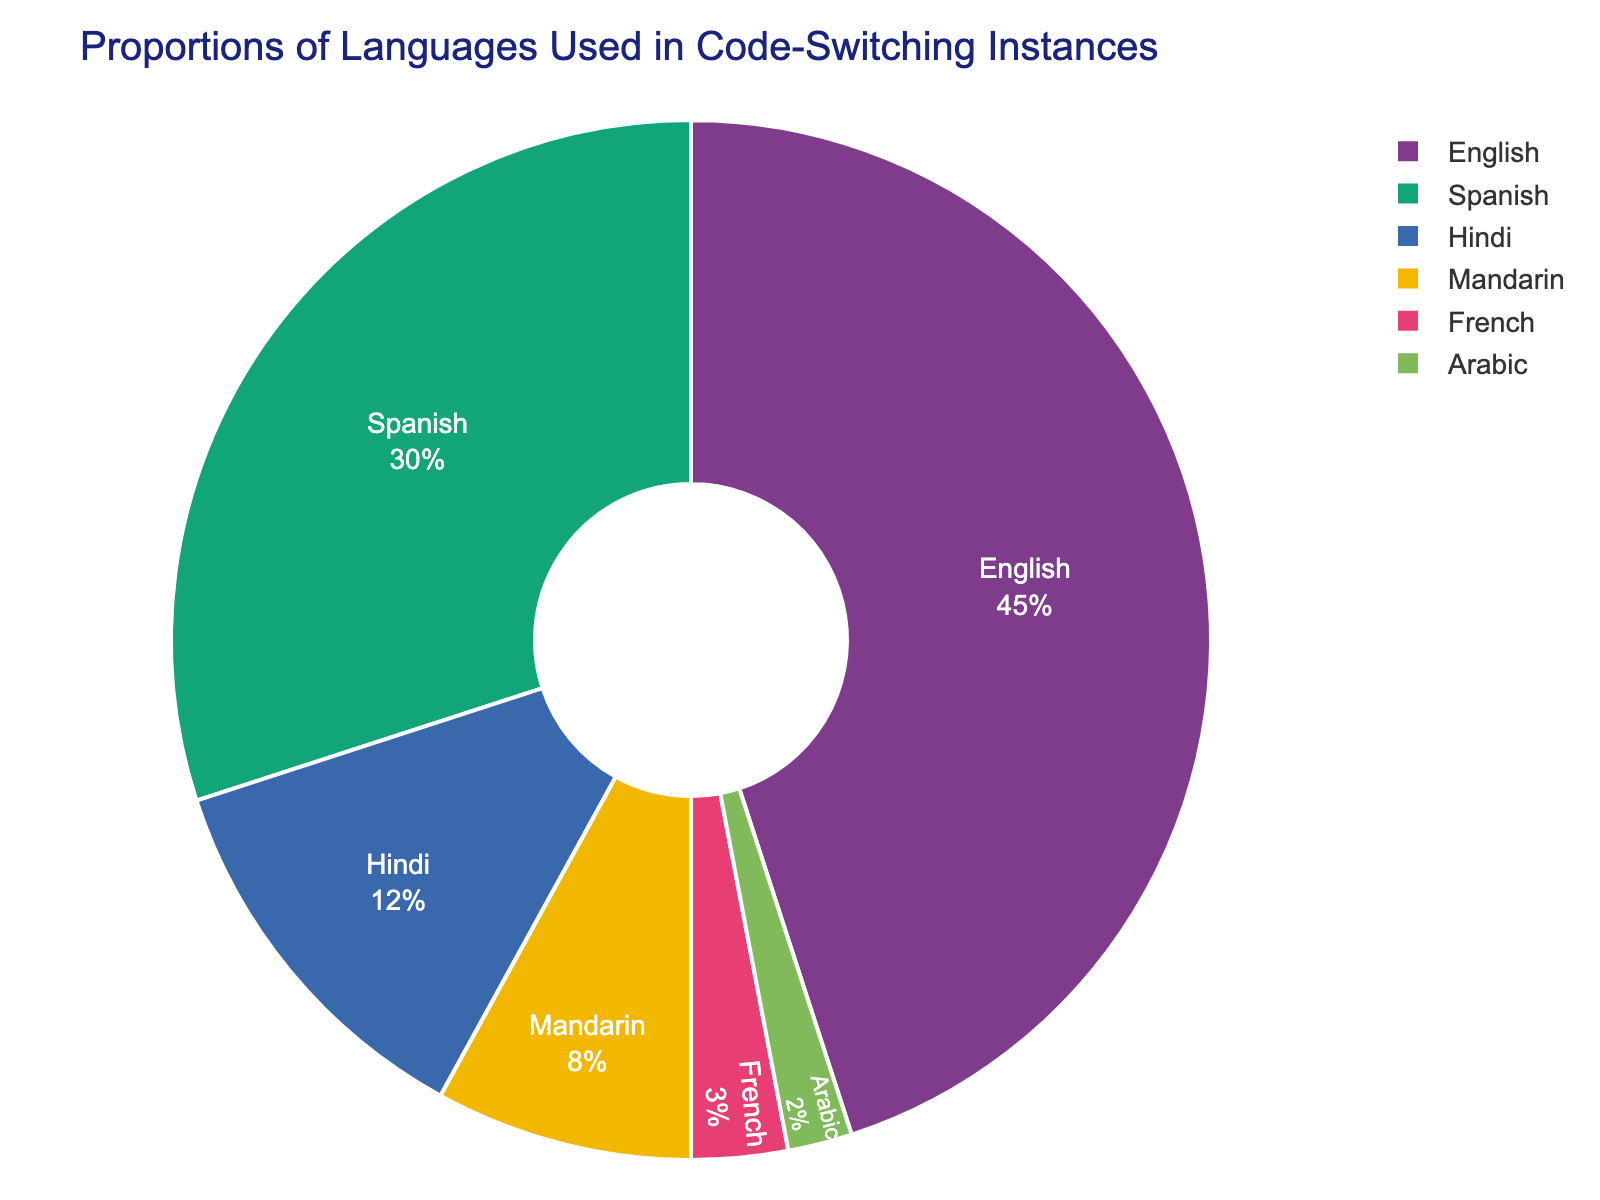What percentage of code-switching instances involve either English or Spanish? To find the total percentage that involves either English or Spanish, add the percentages for both languages. English accounts for 45% and Spanish accounts for 30%. Therefore, the total is 45% + 30% = 75%.
Answer: 75% By how much does the percentage of English code-switching instances exceed the percentage of Spanish instances? Subtract the percentage of Spanish instances from the percentage of English instances. English is 45% and Spanish is 30%. Thus, 45% - 30% = 15%.
Answer: 15% Which language has the smallest proportion of code-switching instances? Review the given percentages for each language. The language with the smallest percentage is Arabic at 2%.
Answer: Arabic How do the combined percentages of Hindi and Mandarin compare to the percentage of Spanish? Add the percentages of Hindi and Mandarin, which are 12% and 8%, respectively. This totals to 12% + 8% = 20%. Compare this to the percentage of Spanish, which is 30%. 20% is less than 30%.
Answer: Less than What is the combined percentage of all languages excluding English? Subtract the percentage of English from the total percentage (100%). The percentage for English is 45%, so the combined percentage for all other languages is 100% - 45% = 55%.
Answer: 55% What language is represented with a proportion of 8% on the pie chart? Reviewing the data provided, Mandarin is the language that accounts for 8% of the code-switching instances.
Answer: Mandarin If Hindi and Mandarin were combined as a single category, what percentage would they represent? Add the percentages for Hindi and Mandarin. Hindi is 12% and Mandarin is 8%. Therefore, the combined category would represent 12% + 8% = 20%.
Answer: 20% Which language has a greater proportion in code-switching instances: French or Arabic? By how much? Compare the percentages for French and Arabic. French is 3% and Arabic is 2%. French has a 1% greater proportion than Arabic.
Answer: French, by 1% 